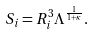Convert formula to latex. <formula><loc_0><loc_0><loc_500><loc_500>S _ { i } = R _ { i } ^ { 3 } \Lambda ^ { \frac { 1 } { 1 + \kappa } } .</formula> 